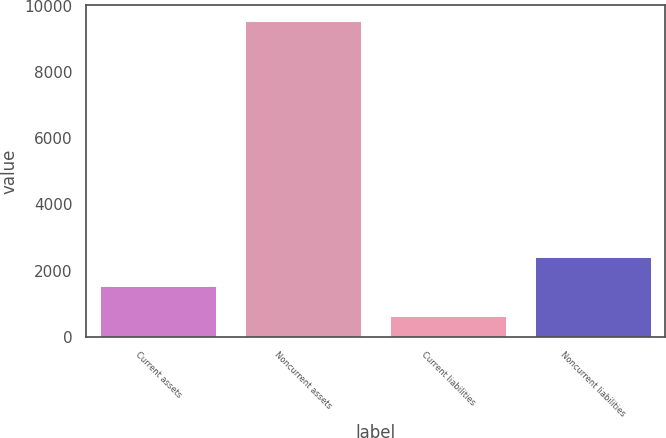Convert chart to OTSL. <chart><loc_0><loc_0><loc_500><loc_500><bar_chart><fcel>Current assets<fcel>Noncurrent assets<fcel>Current liabilities<fcel>Noncurrent liabilities<nl><fcel>1524.6<fcel>9549<fcel>633<fcel>2416.2<nl></chart> 